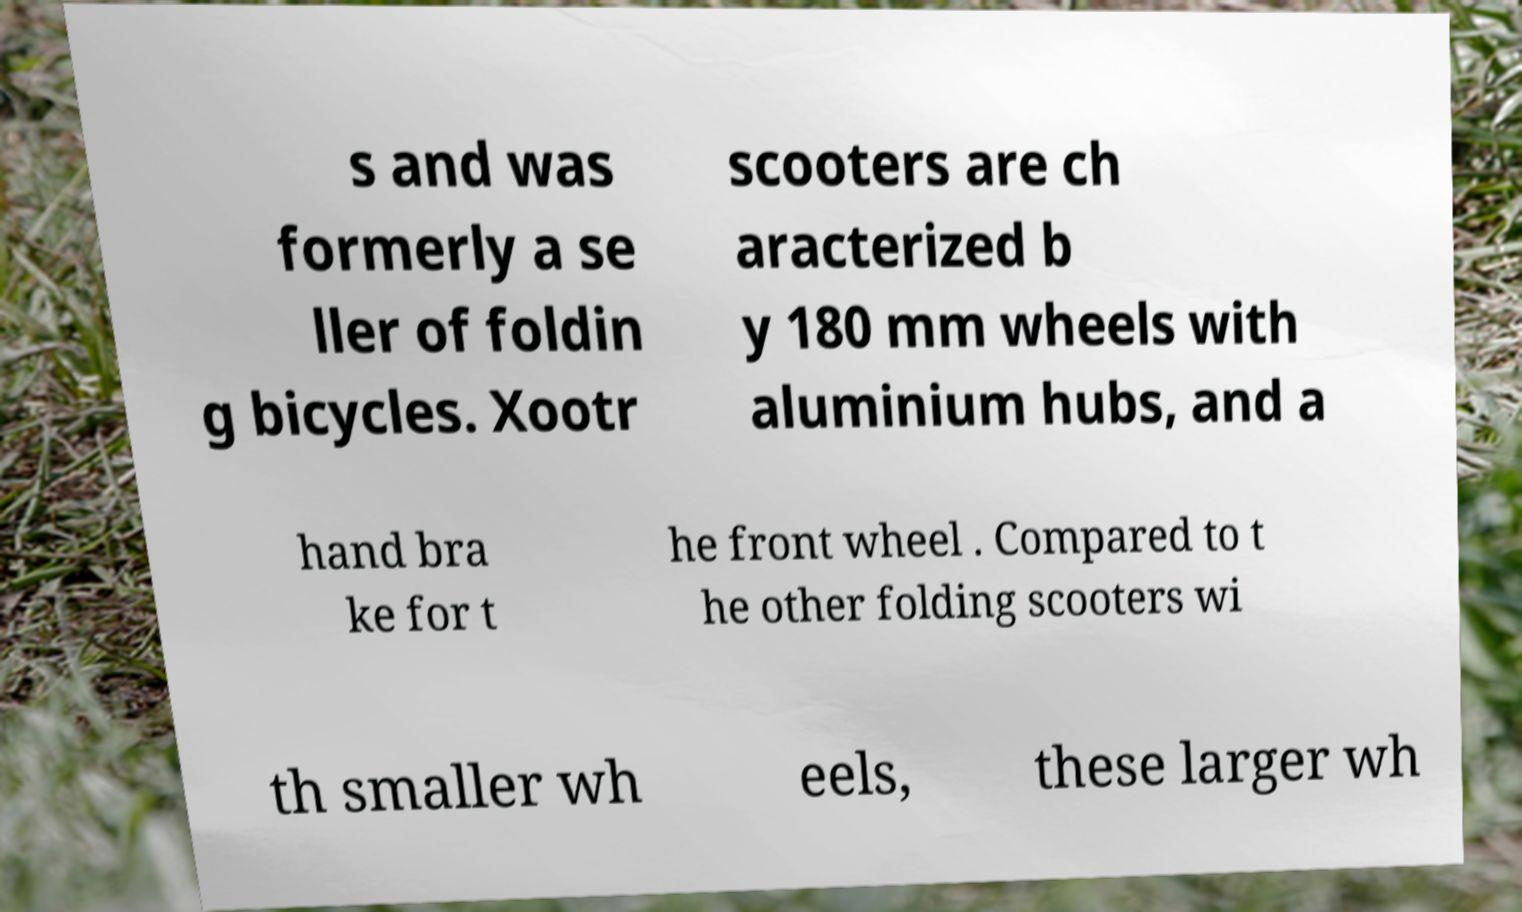Could you extract and type out the text from this image? s and was formerly a se ller of foldin g bicycles. Xootr scooters are ch aracterized b y 180 mm wheels with aluminium hubs, and a hand bra ke for t he front wheel . Compared to t he other folding scooters wi th smaller wh eels, these larger wh 